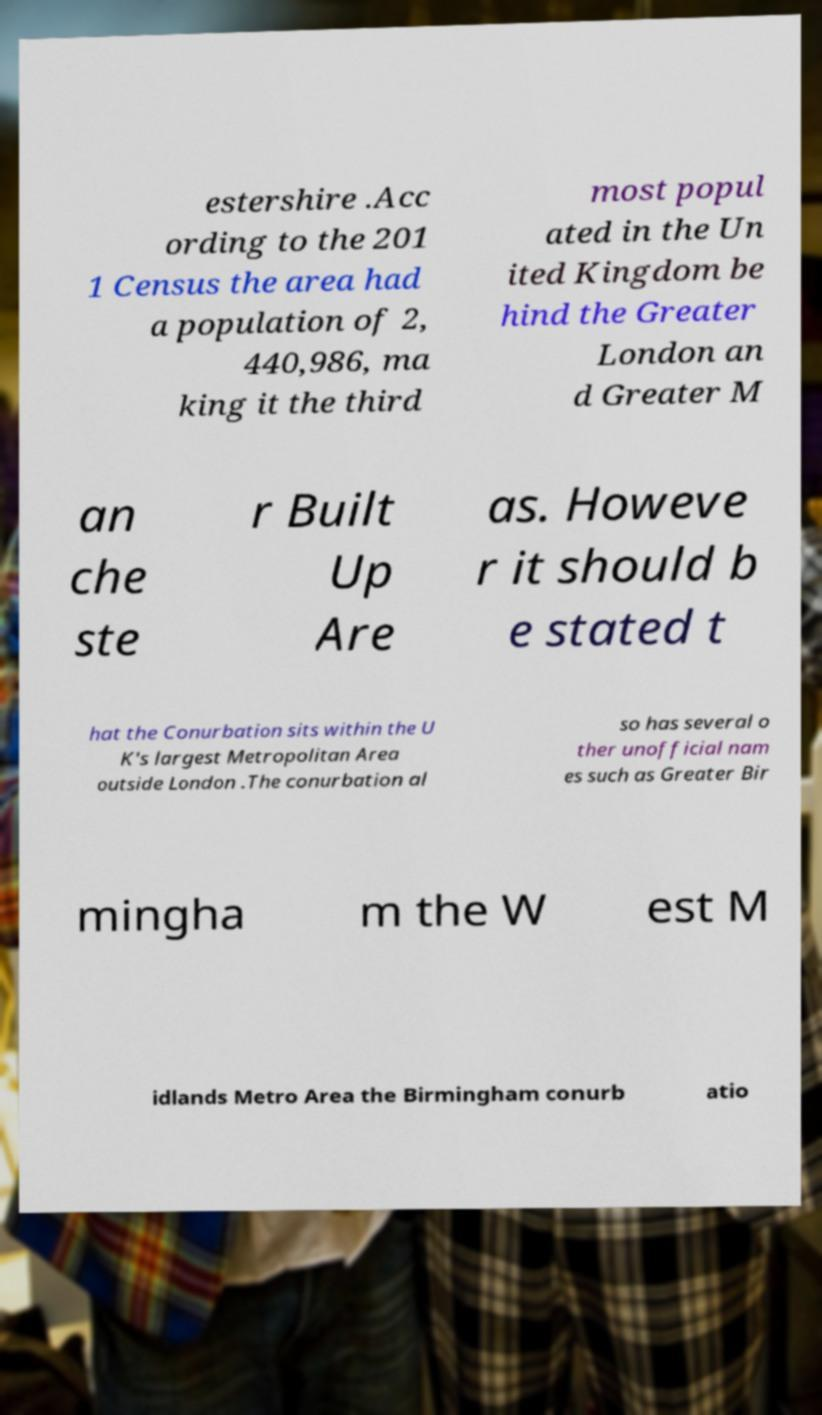For documentation purposes, I need the text within this image transcribed. Could you provide that? estershire .Acc ording to the 201 1 Census the area had a population of 2, 440,986, ma king it the third most popul ated in the Un ited Kingdom be hind the Greater London an d Greater M an che ste r Built Up Are as. Howeve r it should b e stated t hat the Conurbation sits within the U K's largest Metropolitan Area outside London .The conurbation al so has several o ther unofficial nam es such as Greater Bir mingha m the W est M idlands Metro Area the Birmingham conurb atio 